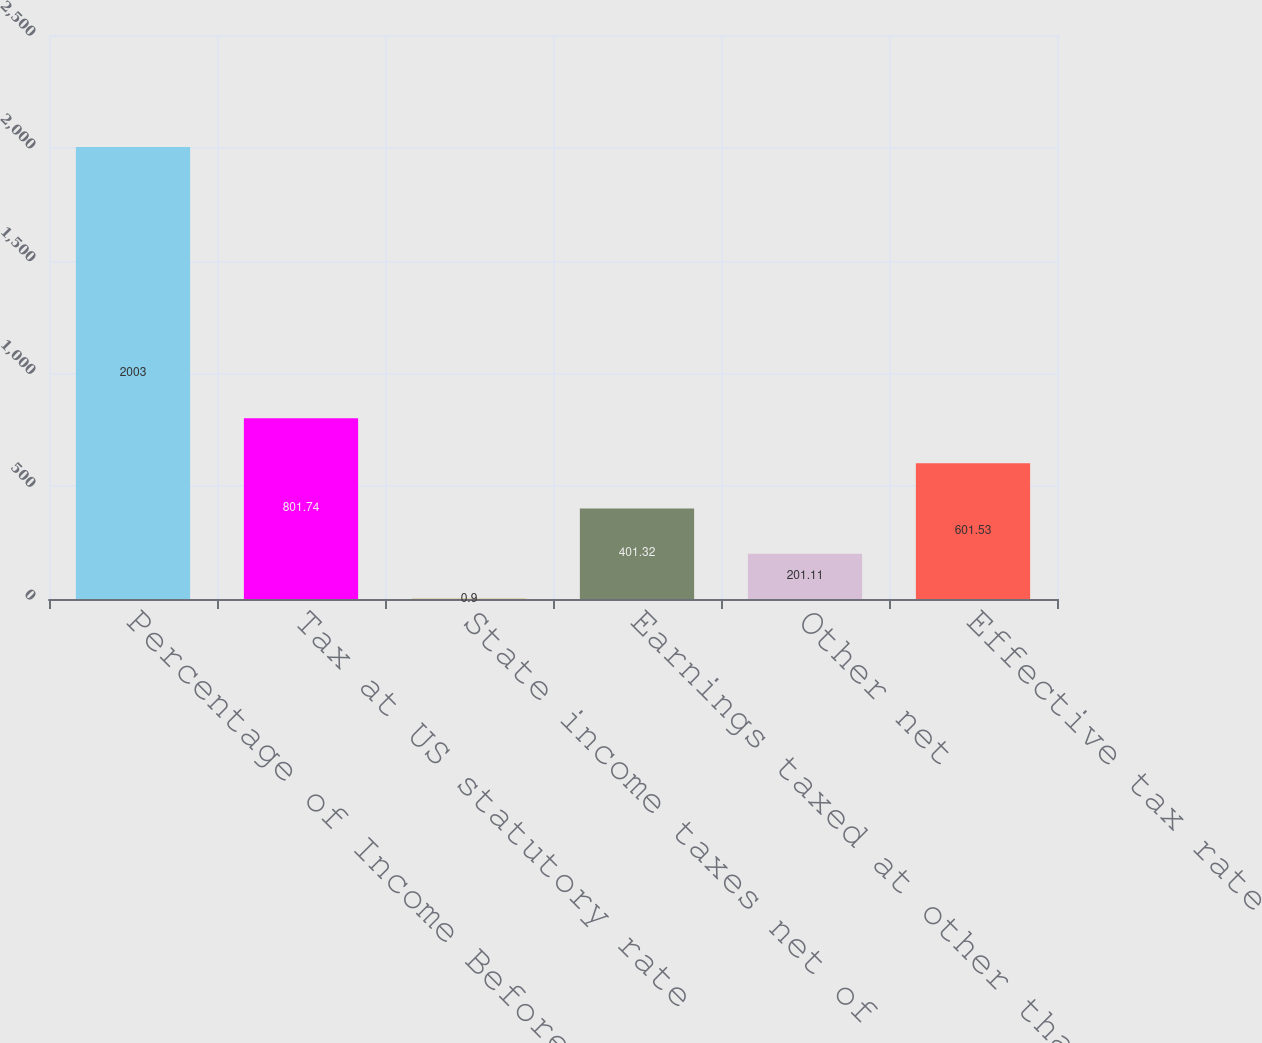Convert chart. <chart><loc_0><loc_0><loc_500><loc_500><bar_chart><fcel>Percentage of Income Before<fcel>Tax at US statutory rate<fcel>State income taxes net of<fcel>Earnings taxed at other than<fcel>Other net<fcel>Effective tax rate<nl><fcel>2003<fcel>801.74<fcel>0.9<fcel>401.32<fcel>201.11<fcel>601.53<nl></chart> 